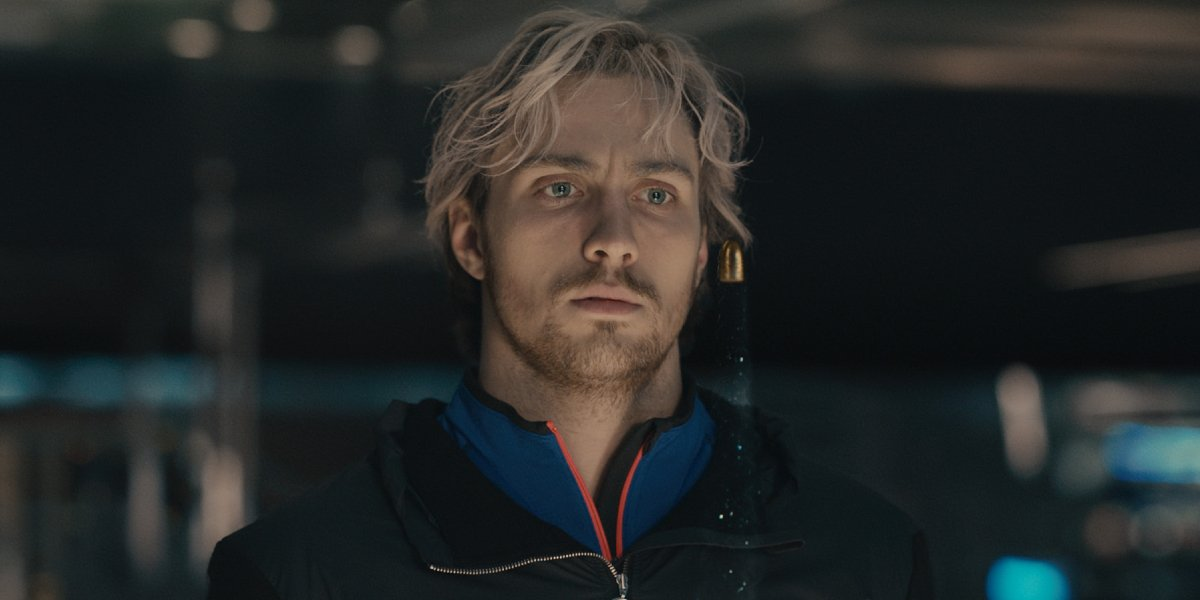Create a detailed realistic scenario where the man is about to meet his long-lost sibling. Standing in the dimly lit aisle of the mall, the man feels his heart race with anticipation. His mind races back to the fragmented memories of a childhood shared with a sibling who was lost in the chaos of their family's separation. The years of searching and the whispers of hope culminate in this moment, where a simple meeting holds the possibility of reuniting long-lost family ties. The ambient sounds of the mall fade into the background as he spots a familiar face walking towards him. Their eyes meet, and in that shared gaze is the recognition of a bond that time could not erase. Emotions flood through him—relief, joy, and a hint of sadness for the years lost. As they embrace, the world around them momentarily stands still, acknowledging the profound significance of this reunion. 